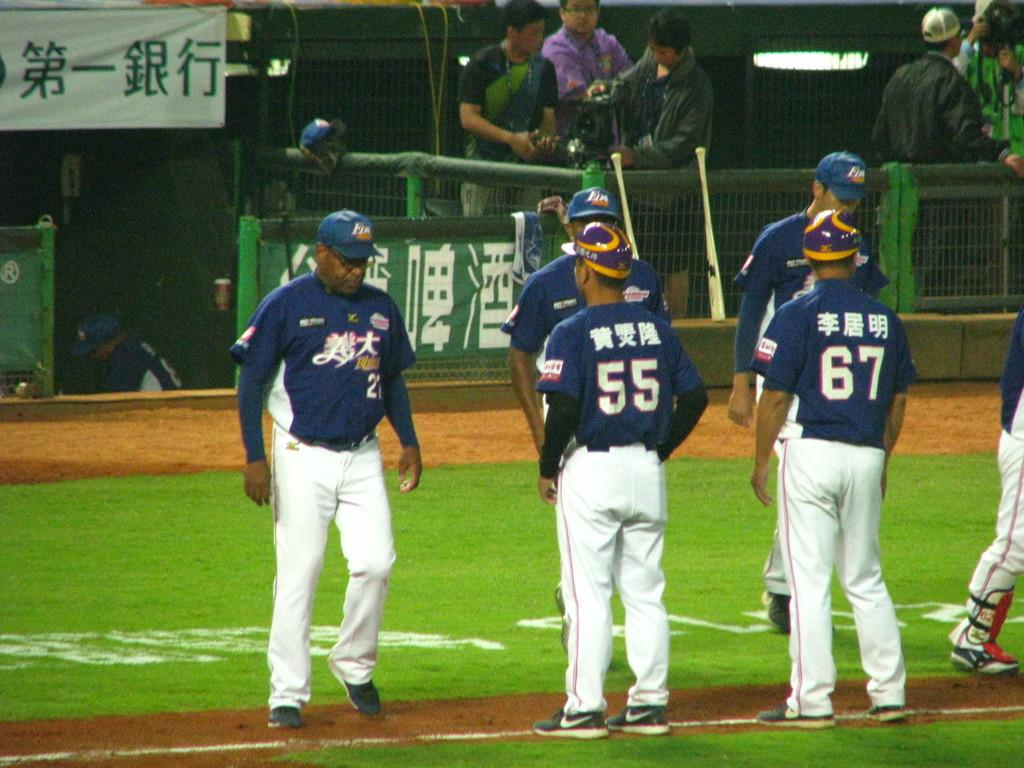<image>
Give a short and clear explanation of the subsequent image. players 27, 55, and 67 talking on field and they have asian lettering on their uniforms 